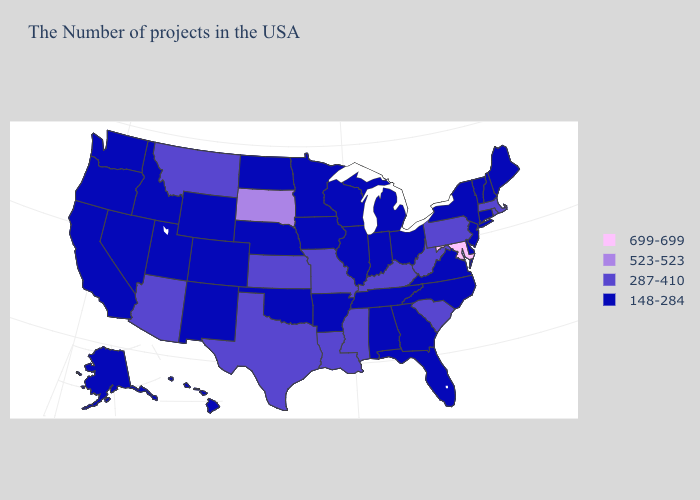Among the states that border Colorado , which have the highest value?
Quick response, please. Kansas, Arizona. What is the value of Georgia?
Be succinct. 148-284. Name the states that have a value in the range 148-284?
Keep it brief. Maine, New Hampshire, Vermont, Connecticut, New York, New Jersey, Delaware, Virginia, North Carolina, Ohio, Florida, Georgia, Michigan, Indiana, Alabama, Tennessee, Wisconsin, Illinois, Arkansas, Minnesota, Iowa, Nebraska, Oklahoma, North Dakota, Wyoming, Colorado, New Mexico, Utah, Idaho, Nevada, California, Washington, Oregon, Alaska, Hawaii. Does Delaware have the highest value in the USA?
Write a very short answer. No. Among the states that border Texas , does Oklahoma have the highest value?
Concise answer only. No. What is the highest value in states that border Utah?
Quick response, please. 287-410. What is the value of Massachusetts?
Keep it brief. 287-410. What is the value of Missouri?
Quick response, please. 287-410. What is the lowest value in the USA?
Concise answer only. 148-284. What is the value of Arizona?
Answer briefly. 287-410. What is the value of Illinois?
Short answer required. 148-284. Does Oklahoma have the lowest value in the South?
Give a very brief answer. Yes. What is the lowest value in the Northeast?
Concise answer only. 148-284. What is the highest value in the MidWest ?
Concise answer only. 523-523. 